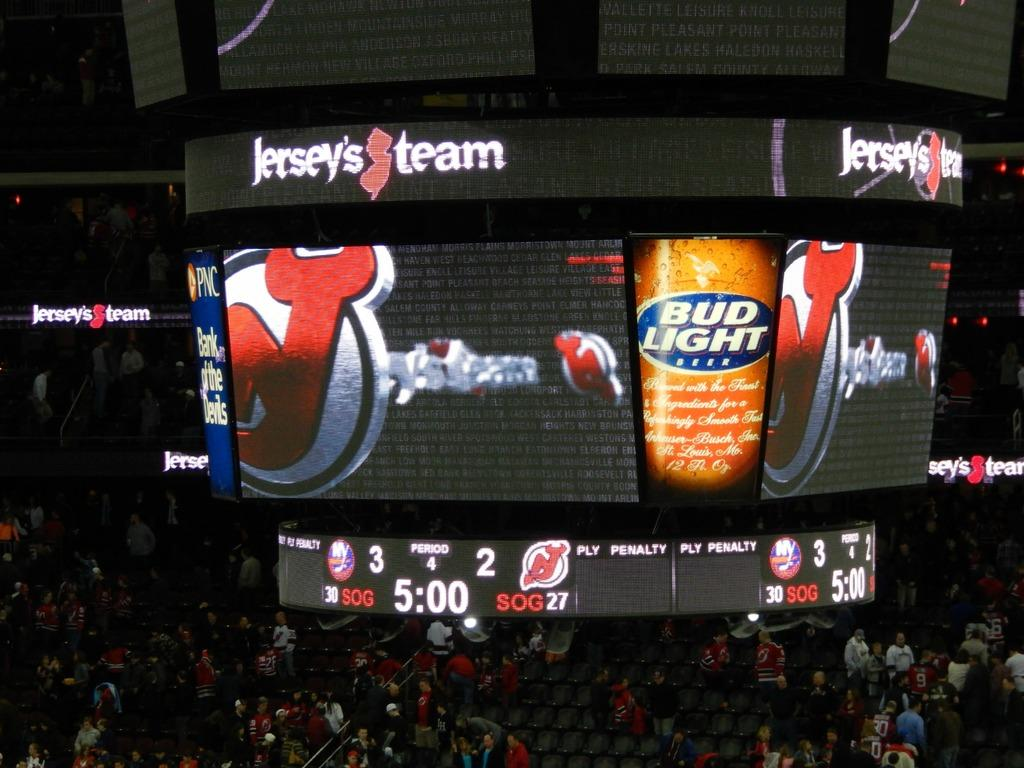<image>
Describe the image concisely. A Bud Light advertisement on a jumbotron for Jersey's team above the crowd at a game. 